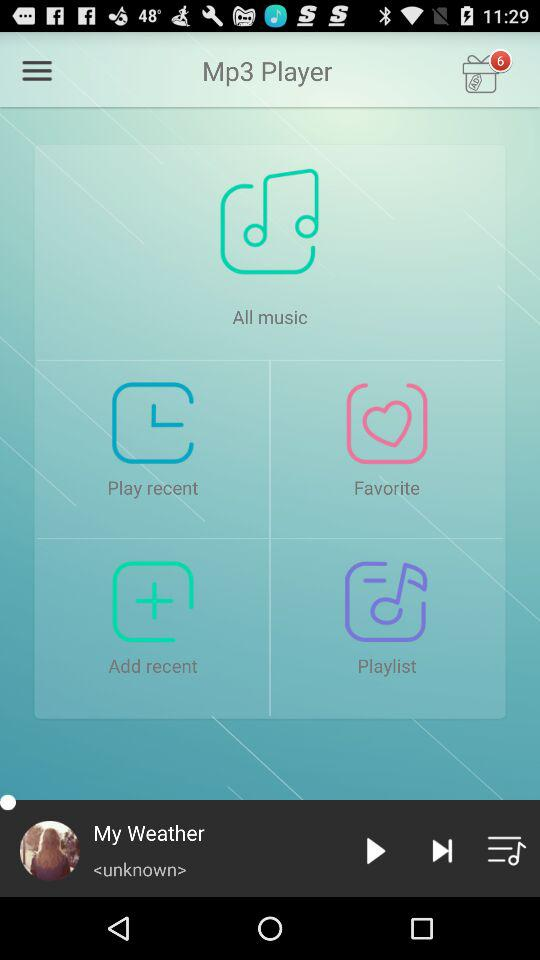What is the name of the song that is paused? The name of the song that is paused is "My Weather". 